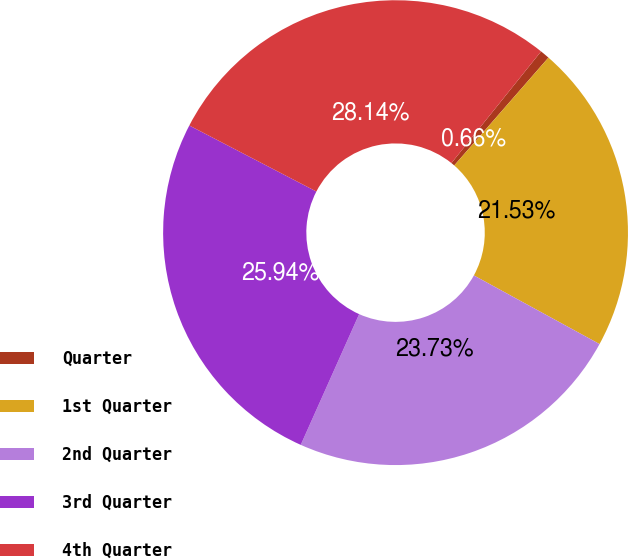<chart> <loc_0><loc_0><loc_500><loc_500><pie_chart><fcel>Quarter<fcel>1st Quarter<fcel>2nd Quarter<fcel>3rd Quarter<fcel>4th Quarter<nl><fcel>0.66%<fcel>21.53%<fcel>23.73%<fcel>25.94%<fcel>28.14%<nl></chart> 